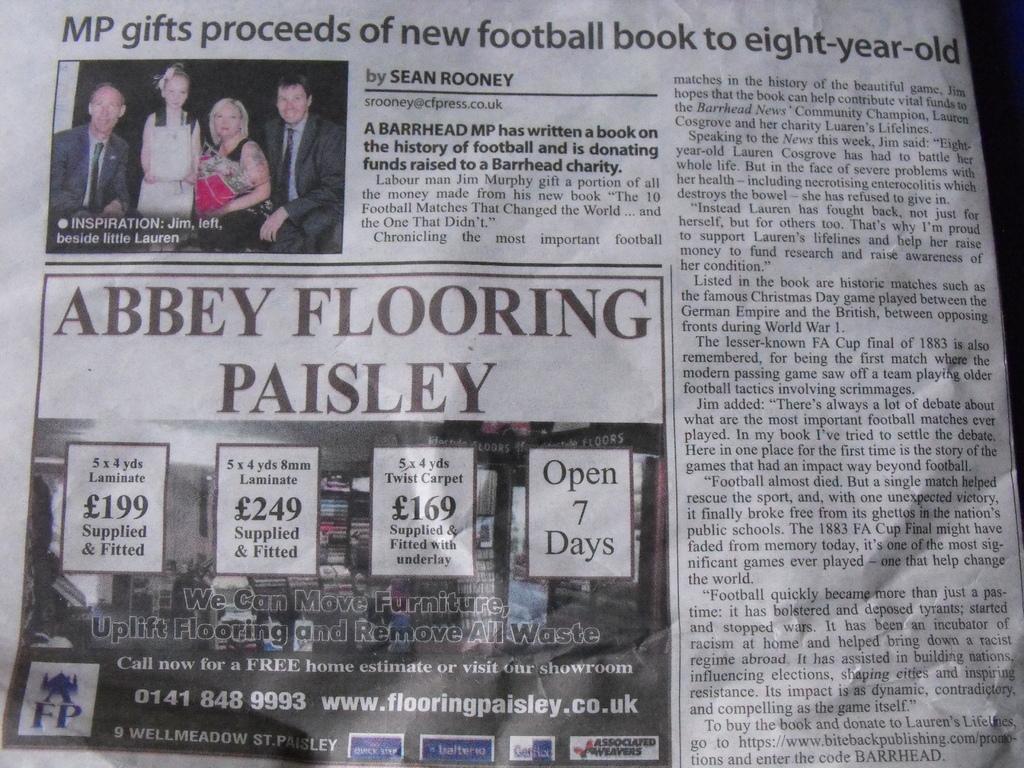How would you summarize this image in a sentence or two? In this image, we can see a newspaper. In this paper, we can see pictures, some information, numbers and few things. Here we can see few people. 